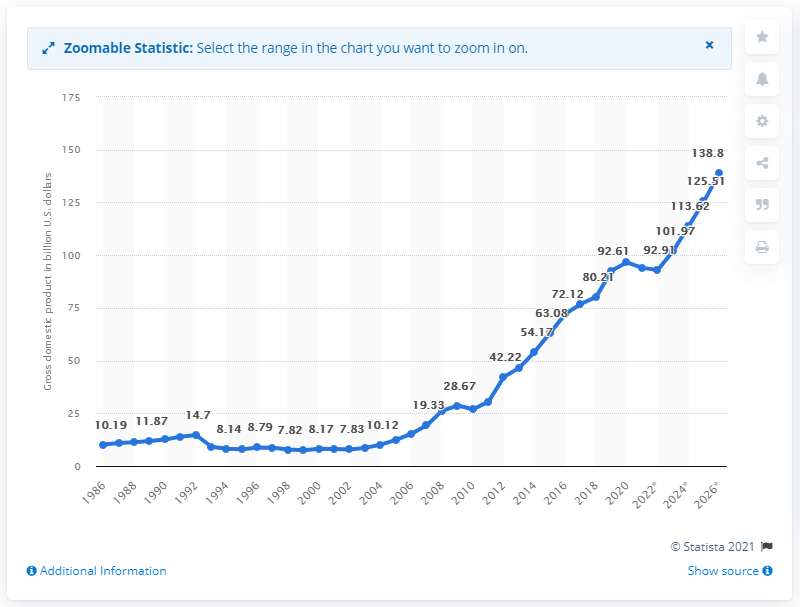Point out several critical features in this image. In 2020, Ethiopia's gross domestic product (GDP) was valued at approximately 96.61 billion dollars. 